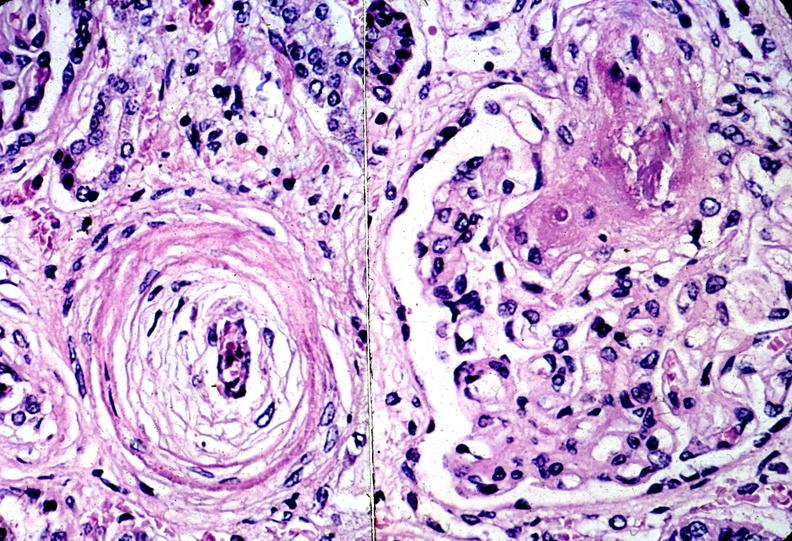where is this?
Answer the question using a single word or phrase. Urinary 